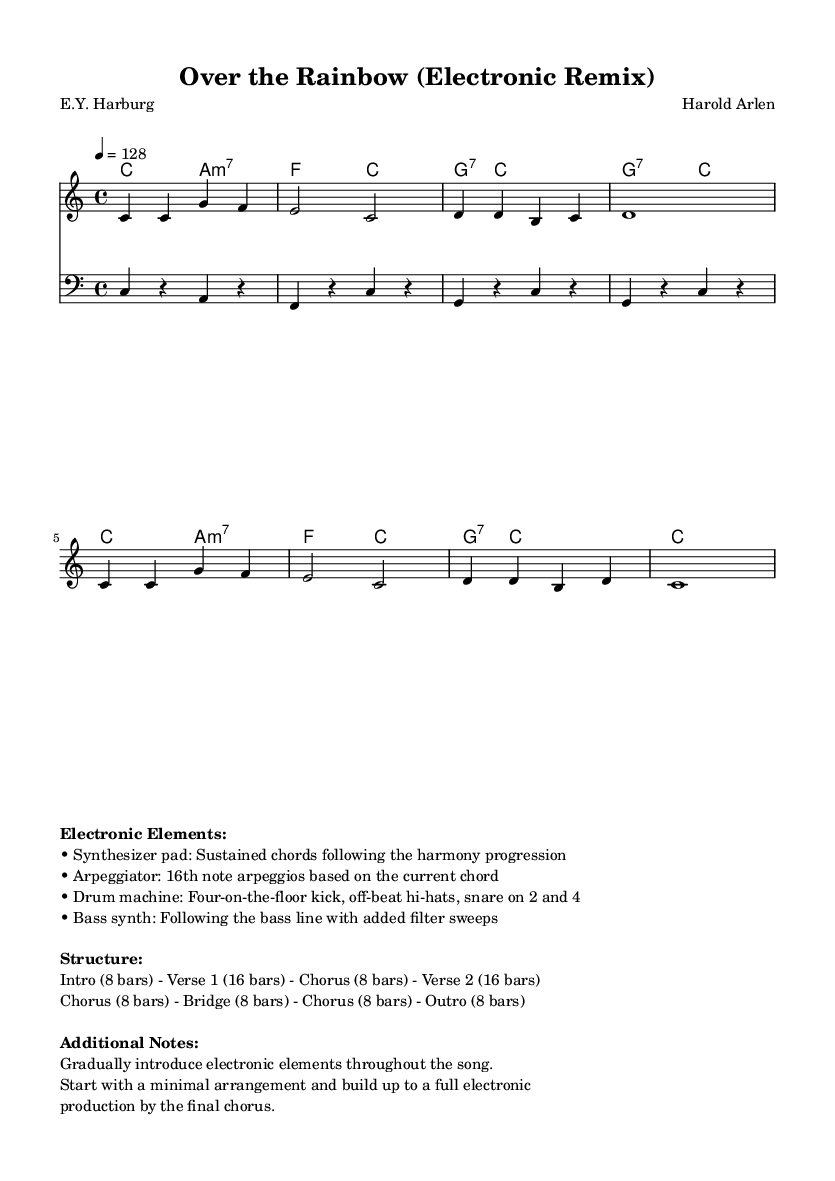What is the key signature of this music? The key signature is C major, which is indicated by the absence of sharps or flats on the staff.
Answer: C major What is the time signature of this music? The time signature is 4/4, which means there are four beats per measure and a quarter note receives one beat. This is indicated at the beginning of the score.
Answer: 4/4 What is the tempo marking of this piece? The tempo marking is indicated as quarter note equals 128, meaning the tempo is relatively fast at a rate of 128 beats per minute.
Answer: 128 What types of electronic elements are introduced in the music? The electronic elements mentioned include a synthesizer pad, arpeggiator, drum machine, and bass synth, which all contribute to the electronic sound of the remix.
Answer: Synthesizer pad, arpeggiator, drum machine, bass synth How many bars are in the bridge section? The bridge section consists of 8 bars, as stated in the structure notes provided in the markup section.
Answer: 8 bars What is the overall structure of the piece? The structure includes an Intro (8 bars), followed by Verse 1 (16 bars), Chorus (8 bars), Verse 2 (16 bars), Chorus (8 bars), Bridge (8 bars), Chorus (8 bars), and Outro (8 bars). This is noted in the markup section for additional notes.
Answer: Intro (8 bars) - Verse 1 (16 bars) - Chorus (8 bars) - Verse 2 (16 bars) - Chorus (8 bars) - Bridge (8 bars) - Chorus (8 bars) - Outro (8 bars) 